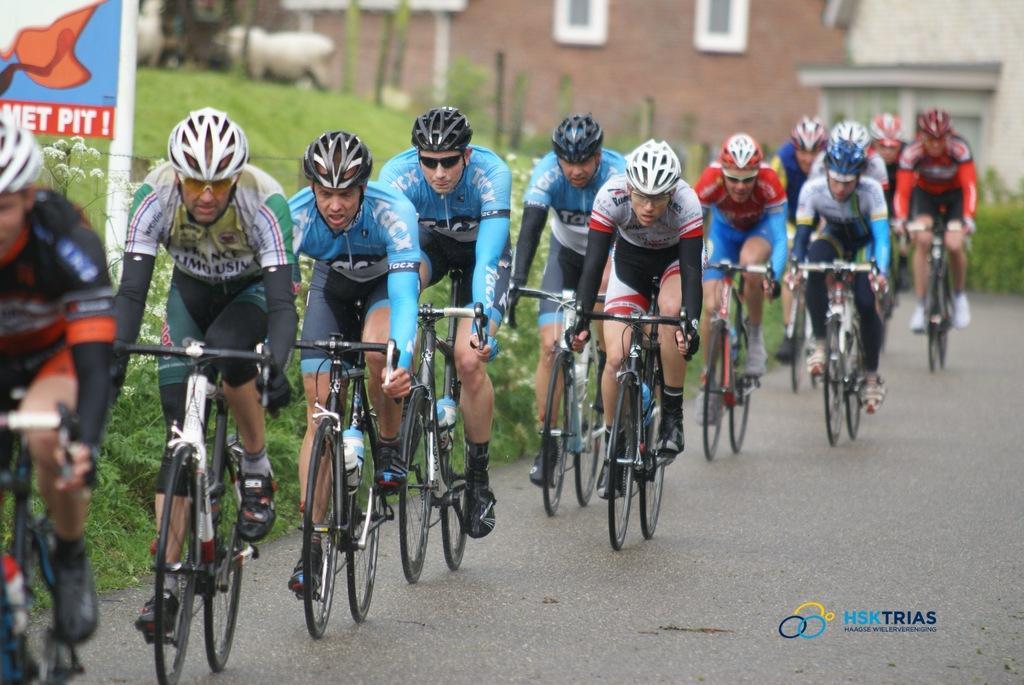Describe this image in one or two sentences. A group of people are riding the cycles on the road, on the left side it is grass and this is the house in the middle of an image. 